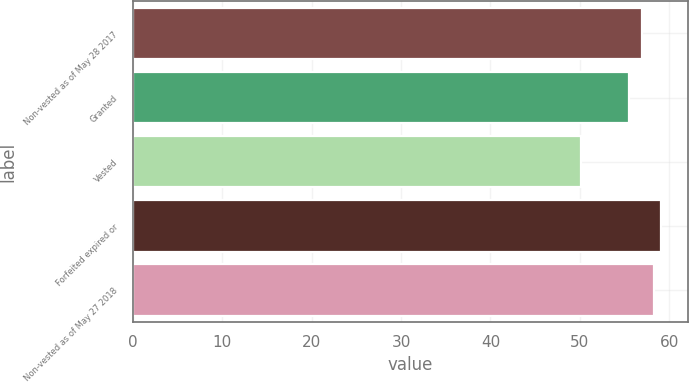Convert chart. <chart><loc_0><loc_0><loc_500><loc_500><bar_chart><fcel>Non-vested as of May 28 2017<fcel>Granted<fcel>Vested<fcel>Forfeited expired or<fcel>Non-vested as of May 27 2018<nl><fcel>56.93<fcel>55.48<fcel>50.14<fcel>59.12<fcel>58.26<nl></chart> 